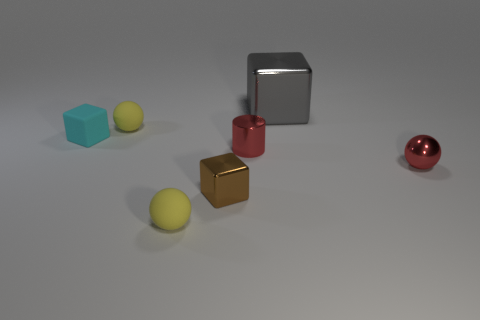Subtract all small yellow matte spheres. How many spheres are left? 1 Add 2 tiny red cubes. How many objects exist? 9 Subtract all gray cubes. How many yellow spheres are left? 2 Subtract all spheres. How many objects are left? 4 Add 5 shiny cylinders. How many shiny cylinders are left? 6 Add 3 brown cylinders. How many brown cylinders exist? 3 Subtract 1 gray blocks. How many objects are left? 6 Subtract all red cubes. Subtract all red spheres. How many cubes are left? 3 Subtract all yellow matte balls. Subtract all yellow rubber things. How many objects are left? 3 